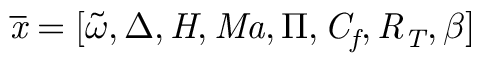<formula> <loc_0><loc_0><loc_500><loc_500>\overline { x } = [ \widetilde { \omega } , \Delta , H , M a , \Pi , C _ { f } , R _ { T } , \beta ]</formula> 